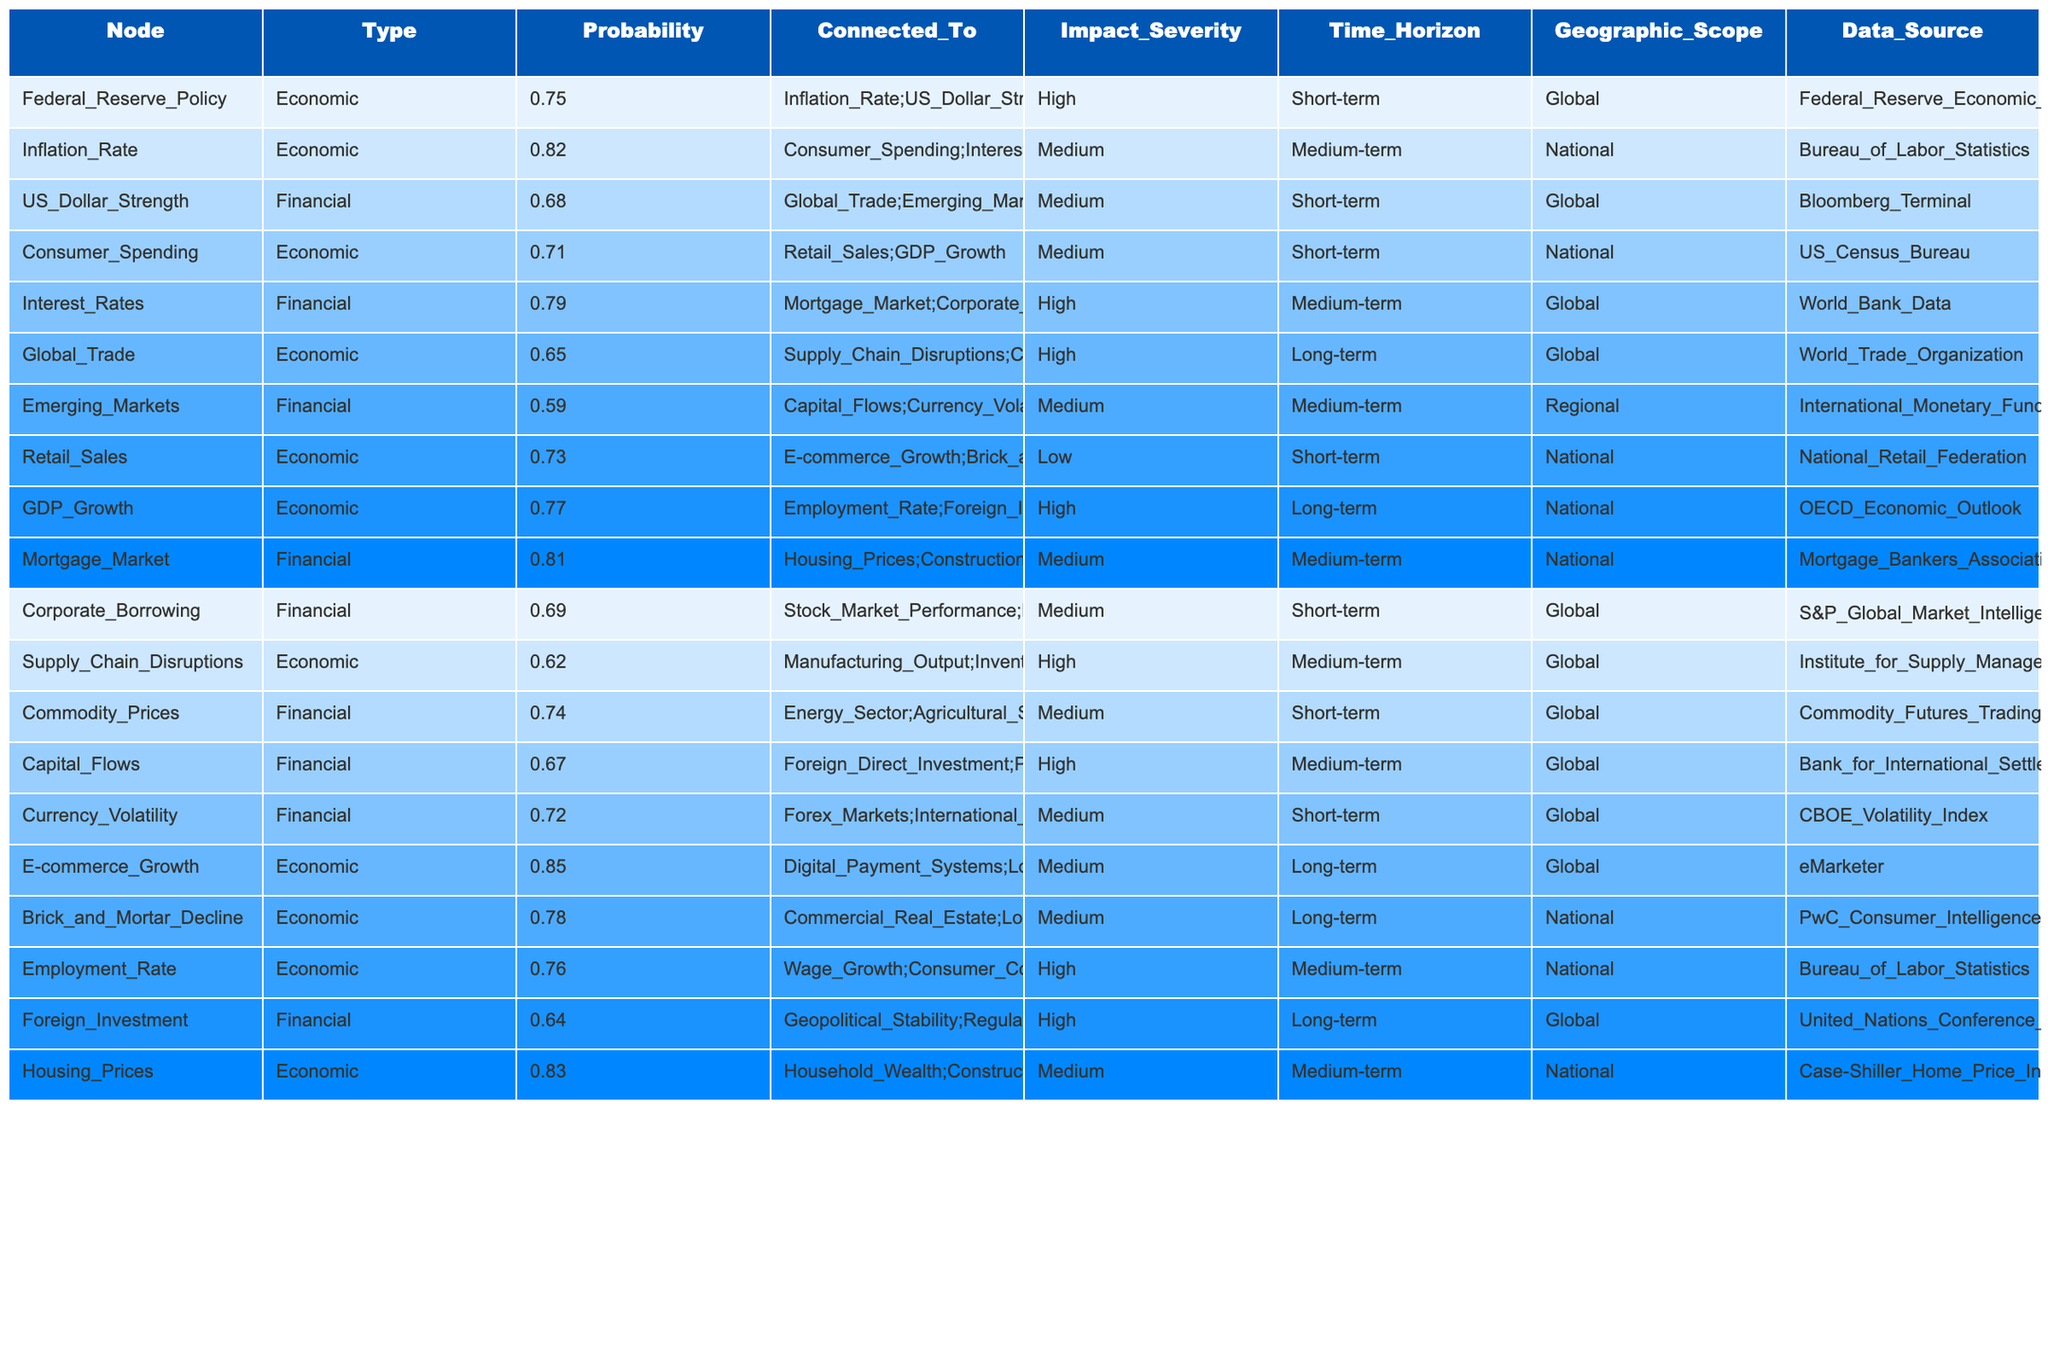What is the probability associated with the Federal Reserve Policy? The table specifies that the probability for the Federal Reserve Policy node is 0.75.
Answer: 0.75 Which economic risk has the highest probability? The node E-commerce Growth has the highest probability at 0.85, which is found directly in the table.
Answer: E-commerce Growth (0.85) What is the impact severity associated with the Global Trade node? The table indicates that Global Trade has a high impact severity.
Answer: High How many nodes are connected to the Interest Rates node? The Interest Rates node is connected to two other nodes: Mortgage Market and Corporate Borrowing, as indicated in the "Connected_To" column.
Answer: 2 What is the average probability of financial nodes in the table? The financial nodes and their probabilities are US Dollar Strength (0.68), Interest Rates (0.79), Emerging Markets (0.59), Mortgage Market (0.81), Corporate Borrowing (0.69), Capital Flows (0.67), Currency Volatility (0.72). Summing these gives 0.68 + 0.79 + 0.59 + 0.81 + 0.69 + 0.67 + 0.72 = 4.95; there are 7 financial nodes, so the average is 4.95 / 7 ≈ 0.71.
Answer: 0.71 Is there any economic risk with a medium impact severity that has a probability threshold above 0.7? The Consumer Spending node has a medium impact severity with a probability of 0.71, which meets both criteria, as seen in the "Impact_Severity" and "Probability" columns.
Answer: Yes What is the relationship between the Federal Reserve Policy and Consumer Spending? Federal Reserve Policy directly connects to the Inflation Rate and US Dollar Strength; Inflation Rate further connects to Consumer Spending. This constitutes an indirect relationship through Inflation Rate.
Answer: Indirect connection via Inflation Rate Calculate the difference in probability between the E-commerce Growth and the Foreign Investment nodes. E-commerce Growth has a probability of 0.85 and Foreign Investment has a probability of 0.64. The difference is 0.85 - 0.64 = 0.21.
Answer: 0.21 Which risk has the lowest probability, and how does it impact the regional markets? The Emerging Markets risk has the lowest probability at 0.59 and it connects to Capital Flows and Currency Volatility, which are essential for the regional financial markets.
Answer: Emerging Markets (0.59) How would a decrease in the Federal Reserve Policy node's probability by 10% affect the connected risks? If Federal Reserve Policy's probability decreases from 0.75 to 0.675, this reduction would likely increase inflation risk, potentially impacting Consumer Spending negatively, as evidenced through the connected nodes’ influence.
Answer: Likely negative impact on connected risks Identify the node with the highest geographic scope and explain its significance. The nodes Global Trade, E-commerce Growth, and Federal Reserve Policy all have a global geographic scope; however, Global Trade is significant as it connects to supply chain disruptions and commodity prices, affecting economies worldwide.
Answer: Global Trade 